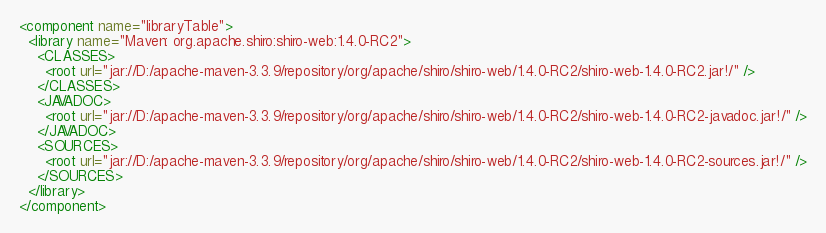Convert code to text. <code><loc_0><loc_0><loc_500><loc_500><_XML_><component name="libraryTable">
  <library name="Maven: org.apache.shiro:shiro-web:1.4.0-RC2">
    <CLASSES>
      <root url="jar://D:/apache-maven-3.3.9/repository/org/apache/shiro/shiro-web/1.4.0-RC2/shiro-web-1.4.0-RC2.jar!/" />
    </CLASSES>
    <JAVADOC>
      <root url="jar://D:/apache-maven-3.3.9/repository/org/apache/shiro/shiro-web/1.4.0-RC2/shiro-web-1.4.0-RC2-javadoc.jar!/" />
    </JAVADOC>
    <SOURCES>
      <root url="jar://D:/apache-maven-3.3.9/repository/org/apache/shiro/shiro-web/1.4.0-RC2/shiro-web-1.4.0-RC2-sources.jar!/" />
    </SOURCES>
  </library>
</component></code> 